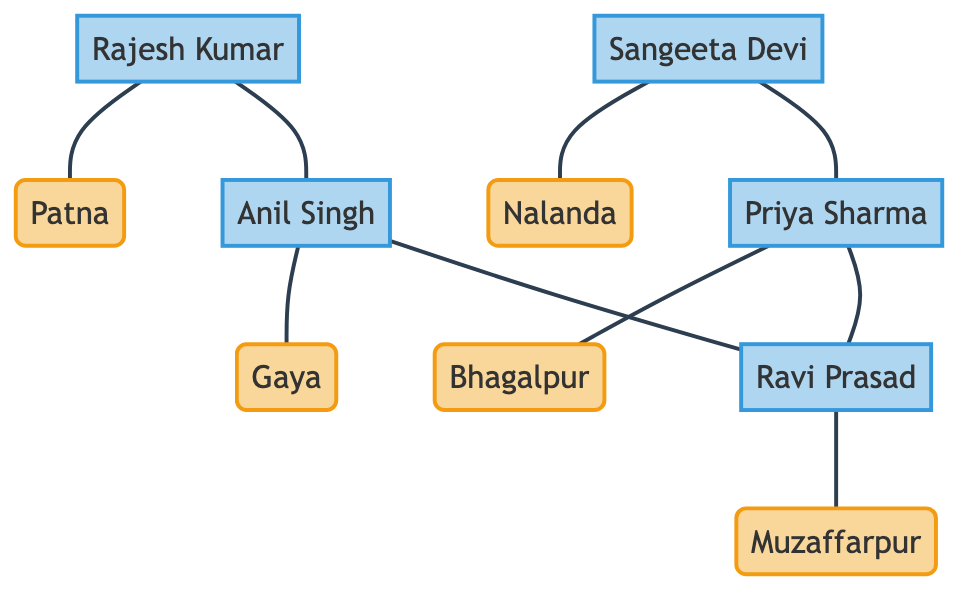What are the names of the regions represented in the diagram? The diagram contains nodes labeled as regions, which are Patna, Nalanda, Gaya, Bhagalpur, and Muzaffarpur. These names can be directly identified as distinct nodes of type "Region."
Answer: Patna, Nalanda, Gaya, Bhagalpur, Muzaffarpur How many grassroots activists are shown in the diagram? By counting the nodes labeled as activists, we find five activists: Rajesh Kumar, Sangeeta Devi, Anil Singh, Priya Sharma, and Ravi Prasad. Thus, the total number of activists can be determined by this count.
Answer: 5 Which activist is associated with Bhagalpur? In the diagram, the node for Bhagalpur is linked to the activist node labeled Priya Sharma, indicating her association with that region. We can trace the edge from the region node to the activist node to confirm this relationship.
Answer: Priya Sharma How many edges connect the activists with one another? Examining the edges in the diagram that connect activists, we count four edges connecting them: Rajesh Kumar to Anil Singh, Sangeeta Devi to Priya Sharma, Anil Singh to Ravi Prasad, and Priya Sharma to Ravi Prasad. This counting process helps to determine the number of direct activist connections.
Answer: 4 Which region has the activist Rajesh Kumar? The node for Rajesh Kumar is directly connected to the region node labeled Patna. By following the edge from the activist to the region, we can confirm which region he represents.
Answer: Patna Is there a direct connection between Nalanda and Gaya? The diagram shows no edge connecting the nodes labeled Nalanda and Gaya, indicating that there is no direct relationship between these two regions within the structure of the graph.
Answer: No How many total edges are present in the graph? By tallying all edges shown in the edges list of the graph, we count a total of six edges, which encompasses connections between activists and regions as well as among activists.
Answer: 9 Which activist links the most regions together? Analyzing the edges, we identify that Ravi Prasad is involved in connections with multiple activists (Priya Sharma and Anil Singh), showing a broader interaction pattern. Thus, we assess each activist’s connections to determine which one links multiple nodes.
Answer: Ravi Prasad 